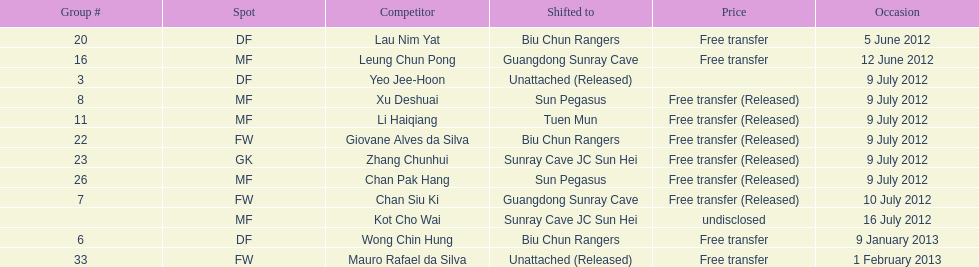What squad # is listed previous to squad # 7? 26. 